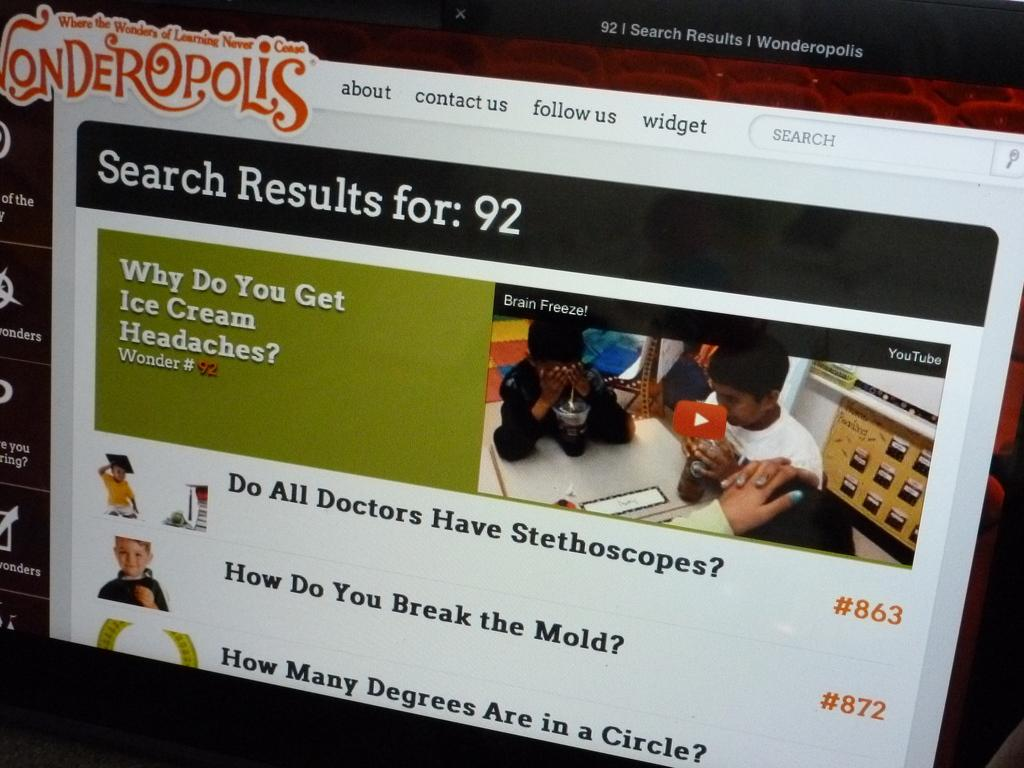What is the main object in the center of the image? There is a screen in the center of the image. What can be seen on the screen? Text and images are visible on the screen. What type of knowledge can be gained from the camp in the image? There is no camp present in the image, so no knowledge can be gained from a camp in this context. 